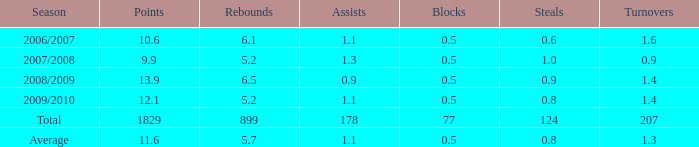What is the maximum rebounds when there are 0.9 steals and fewer than 1.4 turnovers? None. Help me parse the entirety of this table. {'header': ['Season', 'Points', 'Rebounds', 'Assists', 'Blocks', 'Steals', 'Turnovers'], 'rows': [['2006/2007', '10.6', '6.1', '1.1', '0.5', '0.6', '1.6'], ['2007/2008', '9.9', '5.2', '1.3', '0.5', '1.0', '0.9'], ['2008/2009', '13.9', '6.5', '0.9', '0.5', '0.9', '1.4'], ['2009/2010', '12.1', '5.2', '1.1', '0.5', '0.8', '1.4'], ['Total', '1829', '899', '178', '77', '124', '207'], ['Average', '11.6', '5.7', '1.1', '0.5', '0.8', '1.3']]} 